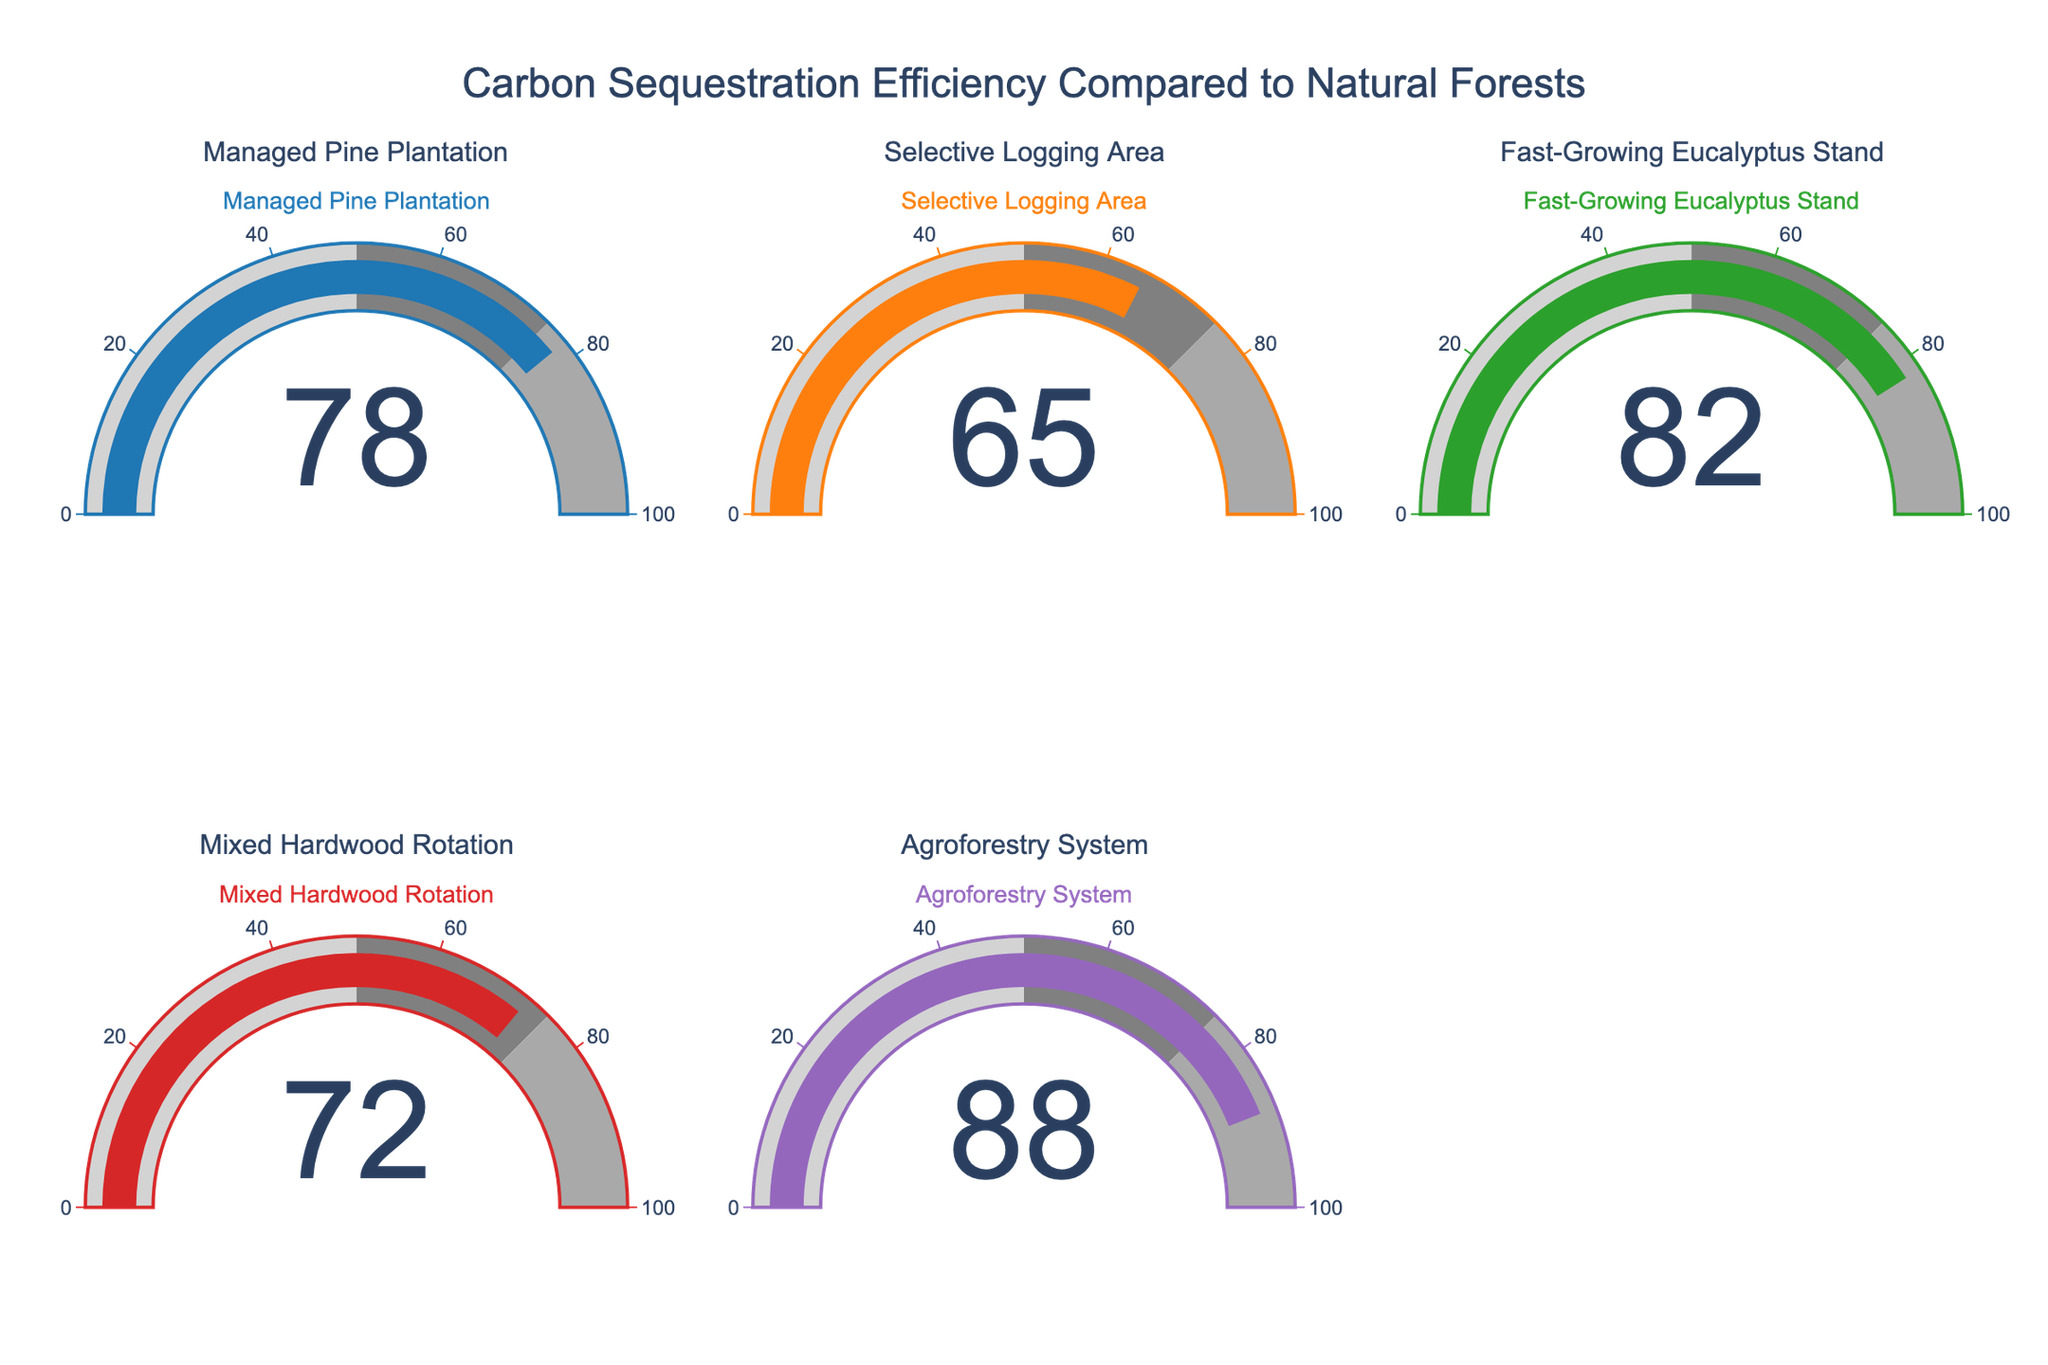What is the title of the figure? The title can be found at the top of the figure, usually occupying a central position. It is meant to provide a concise summary of the visualized data.
Answer: Carbon Sequestration Efficiency Compared to Natural Forests How many locations are represented in the figure? By counting the number of individual gauges, one can determine the total number of different locations depicted in the figure.
Answer: 5 Which location has the highest carbon sequestration efficiency? Identify the highest value from the gauge readings, which indicates the most efficient location.
Answer: Agroforestry System What is the difference in carbon sequestration efficiency between the Managed Pine Plantation and the Selective Logging Area? Locate and subtract the values shown on the gauges for both locations: Managed Pine Plantation (78) and Selective Logging Area (65). The calculation is 78 - 65.
Answer: 13 Which location has a carbon sequestration efficiency closest to the natural forest? Compare the values of each location to 100 (representing natural forest efficiency) and identify the nearest one.
Answer: Agroforestry System What's the sum of carbon sequestration efficiency percentages for all locations? Add up all the gauge values: 78 + 65 + 82 + 72 + 88. The calculation gives the total efficiency percentage across all locations.
Answer: 385 What is the median carbon sequestration efficiency among the locations? To find the median, arrange the values in ascending order: 65, 72, 78, 82, 88. The median is the middle value in this sequence.
Answer: 78 Which location has the lowest carbon sequestration efficiency? Identify the smallest value among the gauge readings to determine which location is the least efficient.
Answer: Selective Logging Area Is the carbon sequestration efficiency of the Fast-Growing Eucalyptus Stand greater than that of the Mixed Hardwood Rotation? Compare the gauge values for Fast-Growing Eucalyptus Stand (82) and Mixed Hardwood Rotation (72). Determine which is greater.
Answer: Yes, 82 is greater than 72 Which two locations have carbon sequestration efficiencies that are within 10 percentage points of each other? Compare each pair of values to see which pairs have a difference of 10 or less. The pairs satisfying this condition are 78 (Managed Pine Plantation) and 72 (Mixed Hardwood Rotation).
Answer: Managed Pine Plantation and Mixed Hardwood Rotation 